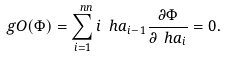Convert formula to latex. <formula><loc_0><loc_0><loc_500><loc_500>\ g O ( \Phi ) = \sum _ { i = 1 } ^ { \ n n } i \ h a _ { i - 1 } \frac { \partial \Phi } { \partial \ h a _ { i } } = 0 .</formula> 